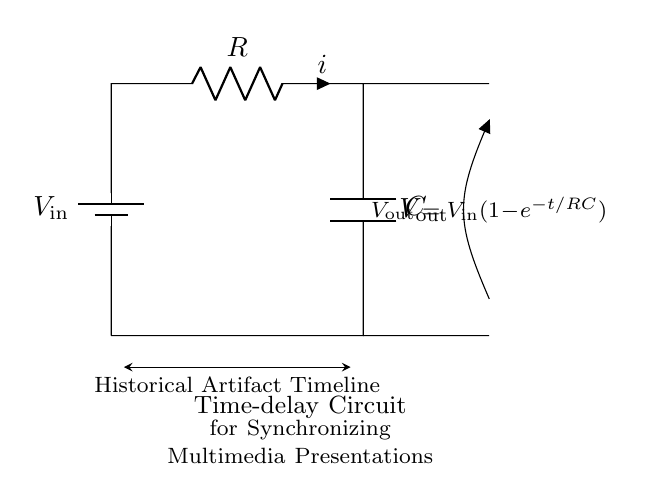What is the input voltage of the circuit? The input voltage is represented by \( V_\text{in} \) in the diagram, indicating the voltage supplied to the circuit.
Answer: \( V_\text{in} \) What components are present in the circuit? The circuit consists of a resistor \( R \) and a capacitor \( C \), along with a battery which provides the input voltage \( V_\text{in} \).
Answer: Resistor and Capacitor What is the expression for the output voltage? The output voltage \( V_\text{out} \) is given by the formula \( V_\text{out} = V_\text{in}(1-e^{-t/RC}) \), indicating how it changes over time based on the input voltage, resistance, and capacitance.
Answer: \( V_\text{out} = V_\text{in}(1-e^{-t/RC}) \) How does the time constant affect the discharge of the capacitor? The time constant \( \tau \) is defined as the product of resistance \( R \) and capacitance \( C \), which determines the rate at which the capacitor charges and discharges. A larger \( RC \) results in a slower charge/discharge rate.
Answer: \( \tau = RC \) What does the term "time-delay" refer to in this circuit? The term "time-delay" refers to the period it takes for the output voltage \( V_\text{out} \) to reach a certain percentage of the input voltage \( V_\text{in} \), commonly related to the charging behavior of the capacitor over time.
Answer: Charging behavior What is the function of the resistor in this circuit? The resistor \( R \) limits the current flow through the circuit and, in combination with the capacitor \( C \), creates a time-delay effect based on the RC time constant, controlling how quickly the voltage changes.
Answer: Limits current flow What would happen to the time delay if the resistance is doubled? If the resistance \( R \) is doubled, the time constant \( \tau \) (which equals \( RC \)) will also double, resulting in a longer time delay for the capacitor to charge to a certain voltage level, thereby increasing the synchronization time.
Answer: Increases time delay 